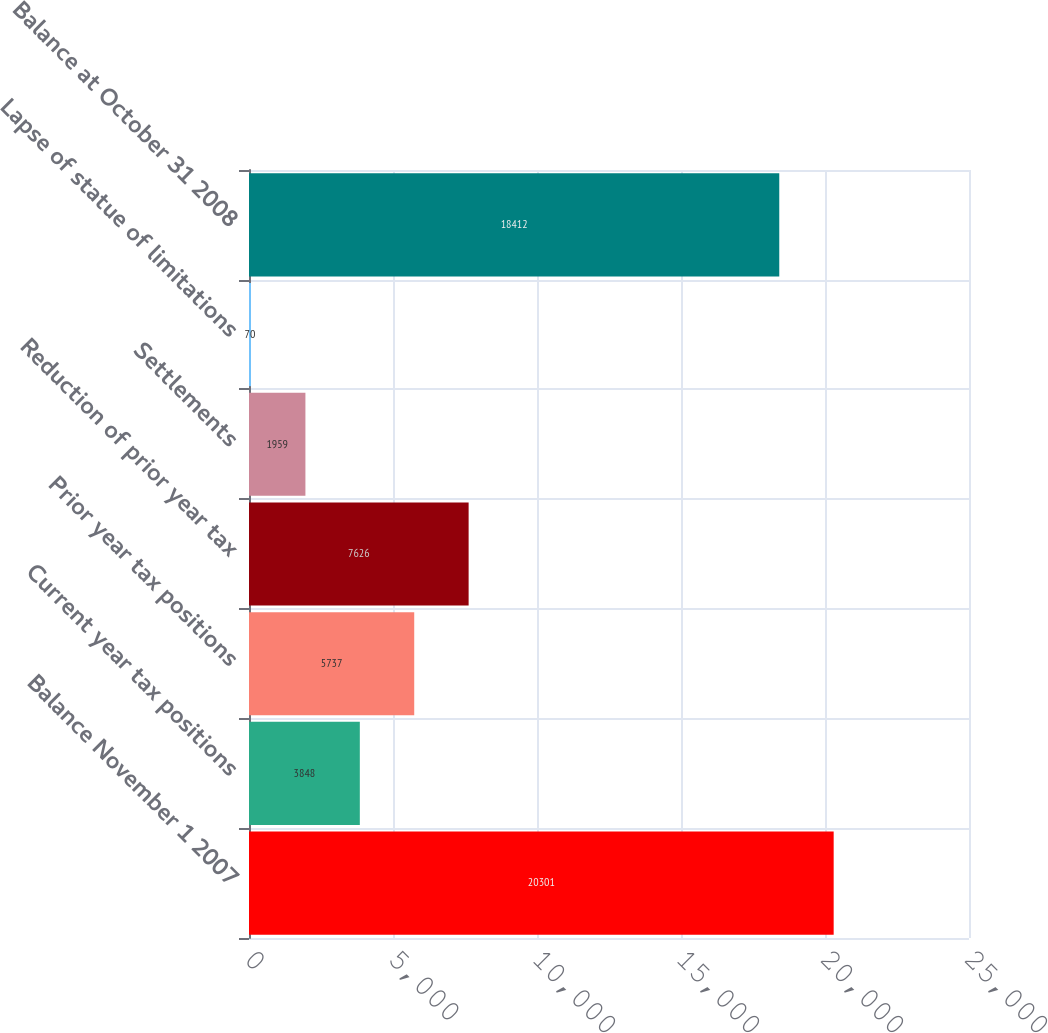Convert chart to OTSL. <chart><loc_0><loc_0><loc_500><loc_500><bar_chart><fcel>Balance November 1 2007<fcel>Current year tax positions<fcel>Prior year tax positions<fcel>Reduction of prior year tax<fcel>Settlements<fcel>Lapse of statue of limitations<fcel>Balance at October 31 2008<nl><fcel>20301<fcel>3848<fcel>5737<fcel>7626<fcel>1959<fcel>70<fcel>18412<nl></chart> 